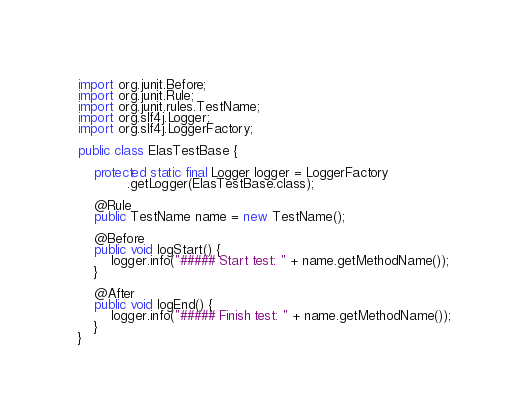<code> <loc_0><loc_0><loc_500><loc_500><_Java_>import org.junit.Before;
import org.junit.Rule;
import org.junit.rules.TestName;
import org.slf4j.Logger;
import org.slf4j.LoggerFactory;

public class ElasTestBase {

    protected static final Logger logger = LoggerFactory
            .getLogger(ElasTestBase.class);

    @Rule
    public TestName name = new TestName();

    @Before
    public void logStart() {
        logger.info("##### Start test: " + name.getMethodName());
    }

    @After
    public void logEnd() {
        logger.info("##### Finish test: " + name.getMethodName());
    }
}
</code> 